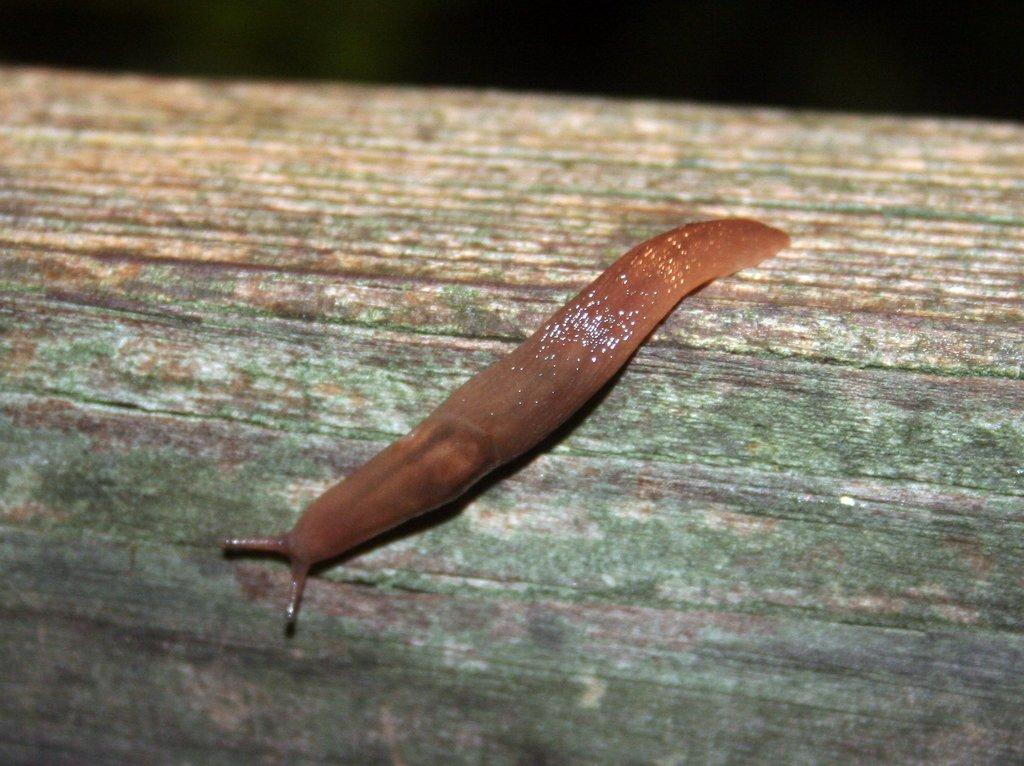In one or two sentences, can you explain what this image depicts? The picture contains a leech, on a wooden surface. At the top it is dark. 